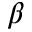Convert formula to latex. <formula><loc_0><loc_0><loc_500><loc_500>\beta</formula> 